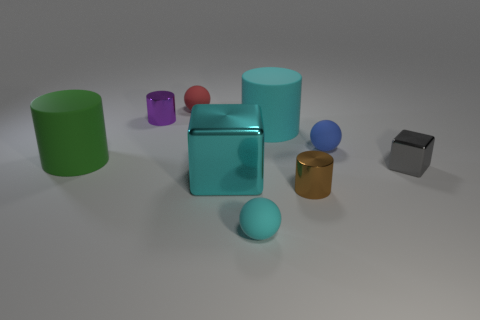Among the objects present, which one is the largest? The largest object in the image is the cyan cube on the right. It has a considerable size compared to the other objects surrounding it. 